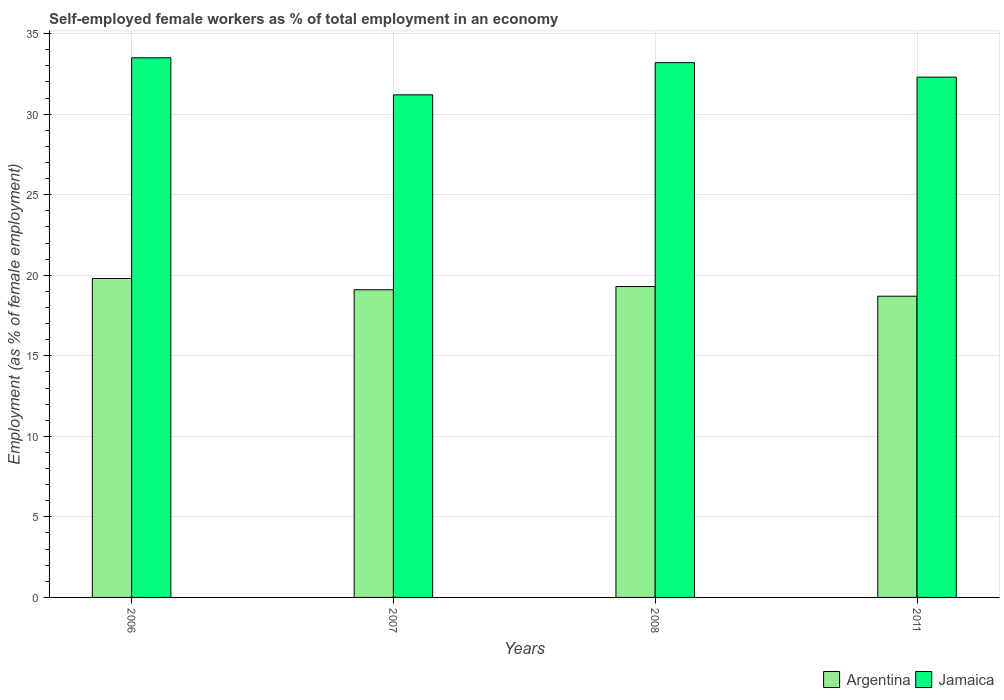How many groups of bars are there?
Provide a succinct answer. 4. Are the number of bars per tick equal to the number of legend labels?
Offer a terse response. Yes. How many bars are there on the 4th tick from the left?
Your answer should be compact. 2. In how many cases, is the number of bars for a given year not equal to the number of legend labels?
Your answer should be compact. 0. What is the percentage of self-employed female workers in Argentina in 2006?
Your answer should be compact. 19.8. Across all years, what is the maximum percentage of self-employed female workers in Argentina?
Provide a short and direct response. 19.8. Across all years, what is the minimum percentage of self-employed female workers in Argentina?
Offer a very short reply. 18.7. In which year was the percentage of self-employed female workers in Argentina maximum?
Ensure brevity in your answer.  2006. What is the total percentage of self-employed female workers in Argentina in the graph?
Ensure brevity in your answer.  76.9. What is the difference between the percentage of self-employed female workers in Argentina in 2006 and that in 2007?
Make the answer very short. 0.7. What is the difference between the percentage of self-employed female workers in Jamaica in 2007 and the percentage of self-employed female workers in Argentina in 2006?
Your response must be concise. 11.4. What is the average percentage of self-employed female workers in Jamaica per year?
Offer a very short reply. 32.55. In the year 2011, what is the difference between the percentage of self-employed female workers in Argentina and percentage of self-employed female workers in Jamaica?
Your response must be concise. -13.6. In how many years, is the percentage of self-employed female workers in Argentina greater than 13 %?
Provide a short and direct response. 4. What is the ratio of the percentage of self-employed female workers in Jamaica in 2006 to that in 2007?
Your response must be concise. 1.07. Is the percentage of self-employed female workers in Argentina in 2006 less than that in 2008?
Provide a succinct answer. No. Is the difference between the percentage of self-employed female workers in Argentina in 2006 and 2007 greater than the difference between the percentage of self-employed female workers in Jamaica in 2006 and 2007?
Make the answer very short. No. What is the difference between the highest and the second highest percentage of self-employed female workers in Jamaica?
Offer a very short reply. 0.3. What is the difference between the highest and the lowest percentage of self-employed female workers in Argentina?
Keep it short and to the point. 1.1. What does the 2nd bar from the left in 2006 represents?
Ensure brevity in your answer.  Jamaica. What does the 2nd bar from the right in 2007 represents?
Provide a succinct answer. Argentina. Are the values on the major ticks of Y-axis written in scientific E-notation?
Keep it short and to the point. No. Where does the legend appear in the graph?
Your response must be concise. Bottom right. How are the legend labels stacked?
Your answer should be very brief. Horizontal. What is the title of the graph?
Your response must be concise. Self-employed female workers as % of total employment in an economy. Does "Lebanon" appear as one of the legend labels in the graph?
Provide a short and direct response. No. What is the label or title of the Y-axis?
Keep it short and to the point. Employment (as % of female employment). What is the Employment (as % of female employment) of Argentina in 2006?
Offer a very short reply. 19.8. What is the Employment (as % of female employment) in Jamaica in 2006?
Your response must be concise. 33.5. What is the Employment (as % of female employment) in Argentina in 2007?
Your response must be concise. 19.1. What is the Employment (as % of female employment) in Jamaica in 2007?
Provide a short and direct response. 31.2. What is the Employment (as % of female employment) of Argentina in 2008?
Keep it short and to the point. 19.3. What is the Employment (as % of female employment) of Jamaica in 2008?
Make the answer very short. 33.2. What is the Employment (as % of female employment) in Argentina in 2011?
Ensure brevity in your answer.  18.7. What is the Employment (as % of female employment) in Jamaica in 2011?
Give a very brief answer. 32.3. Across all years, what is the maximum Employment (as % of female employment) of Argentina?
Your answer should be very brief. 19.8. Across all years, what is the maximum Employment (as % of female employment) in Jamaica?
Offer a very short reply. 33.5. Across all years, what is the minimum Employment (as % of female employment) in Argentina?
Provide a short and direct response. 18.7. Across all years, what is the minimum Employment (as % of female employment) of Jamaica?
Offer a terse response. 31.2. What is the total Employment (as % of female employment) in Argentina in the graph?
Your response must be concise. 76.9. What is the total Employment (as % of female employment) in Jamaica in the graph?
Your answer should be compact. 130.2. What is the difference between the Employment (as % of female employment) of Argentina in 2006 and that in 2007?
Ensure brevity in your answer.  0.7. What is the difference between the Employment (as % of female employment) in Jamaica in 2006 and that in 2007?
Offer a very short reply. 2.3. What is the difference between the Employment (as % of female employment) in Argentina in 2006 and that in 2008?
Your answer should be very brief. 0.5. What is the difference between the Employment (as % of female employment) of Jamaica in 2006 and that in 2008?
Your answer should be compact. 0.3. What is the difference between the Employment (as % of female employment) in Argentina in 2006 and that in 2011?
Offer a terse response. 1.1. What is the difference between the Employment (as % of female employment) in Argentina in 2007 and that in 2008?
Provide a succinct answer. -0.2. What is the difference between the Employment (as % of female employment) of Jamaica in 2007 and that in 2008?
Offer a terse response. -2. What is the difference between the Employment (as % of female employment) in Jamaica in 2007 and that in 2011?
Provide a succinct answer. -1.1. What is the difference between the Employment (as % of female employment) of Argentina in 2007 and the Employment (as % of female employment) of Jamaica in 2008?
Your response must be concise. -14.1. What is the difference between the Employment (as % of female employment) of Argentina in 2007 and the Employment (as % of female employment) of Jamaica in 2011?
Offer a very short reply. -13.2. What is the average Employment (as % of female employment) in Argentina per year?
Your response must be concise. 19.23. What is the average Employment (as % of female employment) in Jamaica per year?
Ensure brevity in your answer.  32.55. In the year 2006, what is the difference between the Employment (as % of female employment) in Argentina and Employment (as % of female employment) in Jamaica?
Give a very brief answer. -13.7. In the year 2007, what is the difference between the Employment (as % of female employment) of Argentina and Employment (as % of female employment) of Jamaica?
Your answer should be very brief. -12.1. In the year 2008, what is the difference between the Employment (as % of female employment) in Argentina and Employment (as % of female employment) in Jamaica?
Provide a short and direct response. -13.9. In the year 2011, what is the difference between the Employment (as % of female employment) in Argentina and Employment (as % of female employment) in Jamaica?
Your answer should be compact. -13.6. What is the ratio of the Employment (as % of female employment) of Argentina in 2006 to that in 2007?
Keep it short and to the point. 1.04. What is the ratio of the Employment (as % of female employment) of Jamaica in 2006 to that in 2007?
Your answer should be compact. 1.07. What is the ratio of the Employment (as % of female employment) in Argentina in 2006 to that in 2008?
Provide a short and direct response. 1.03. What is the ratio of the Employment (as % of female employment) of Argentina in 2006 to that in 2011?
Your answer should be compact. 1.06. What is the ratio of the Employment (as % of female employment) of Jamaica in 2006 to that in 2011?
Your answer should be very brief. 1.04. What is the ratio of the Employment (as % of female employment) in Argentina in 2007 to that in 2008?
Keep it short and to the point. 0.99. What is the ratio of the Employment (as % of female employment) of Jamaica in 2007 to that in 2008?
Offer a terse response. 0.94. What is the ratio of the Employment (as % of female employment) of Argentina in 2007 to that in 2011?
Give a very brief answer. 1.02. What is the ratio of the Employment (as % of female employment) in Jamaica in 2007 to that in 2011?
Provide a short and direct response. 0.97. What is the ratio of the Employment (as % of female employment) in Argentina in 2008 to that in 2011?
Offer a very short reply. 1.03. What is the ratio of the Employment (as % of female employment) of Jamaica in 2008 to that in 2011?
Give a very brief answer. 1.03. What is the difference between the highest and the second highest Employment (as % of female employment) in Argentina?
Provide a succinct answer. 0.5. What is the difference between the highest and the second highest Employment (as % of female employment) in Jamaica?
Offer a terse response. 0.3. 